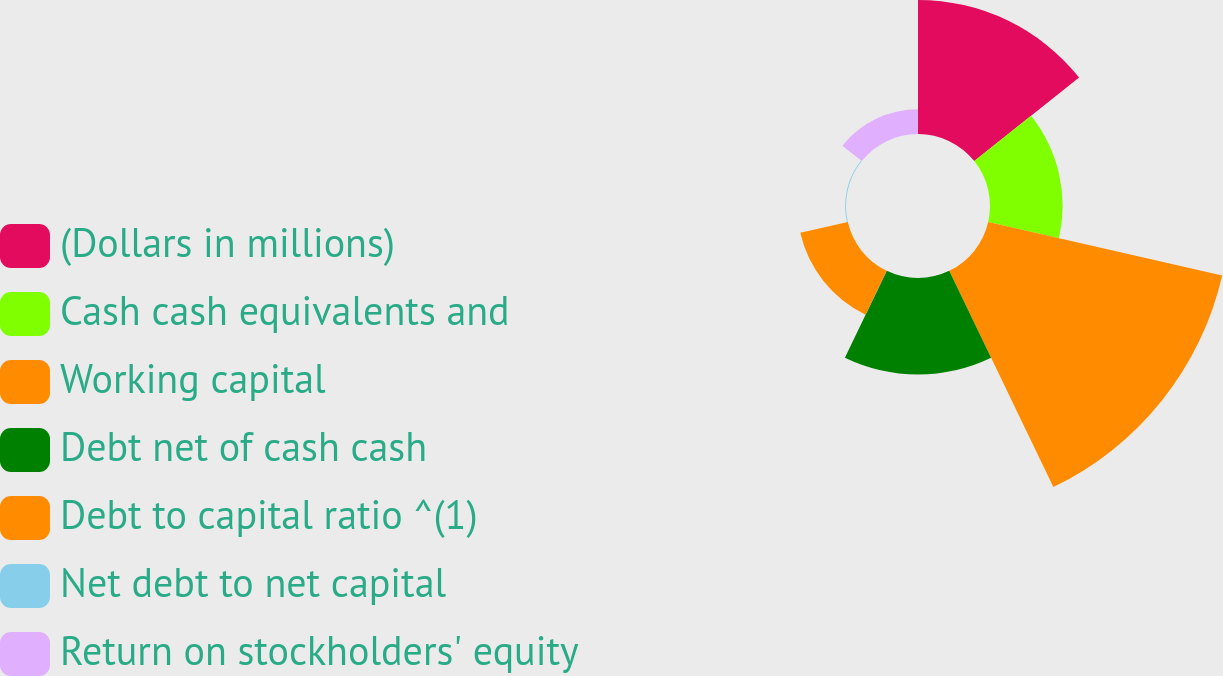Convert chart to OTSL. <chart><loc_0><loc_0><loc_500><loc_500><pie_chart><fcel>(Dollars in millions)<fcel>Cash cash equivalents and<fcel>Working capital<fcel>Debt net of cash cash<fcel>Debt to capital ratio ^(1)<fcel>Net debt to net capital<fcel>Return on stockholders' equity<nl><fcel>21.71%<fcel>11.76%<fcel>38.87%<fcel>15.63%<fcel>7.89%<fcel>0.14%<fcel>4.01%<nl></chart> 